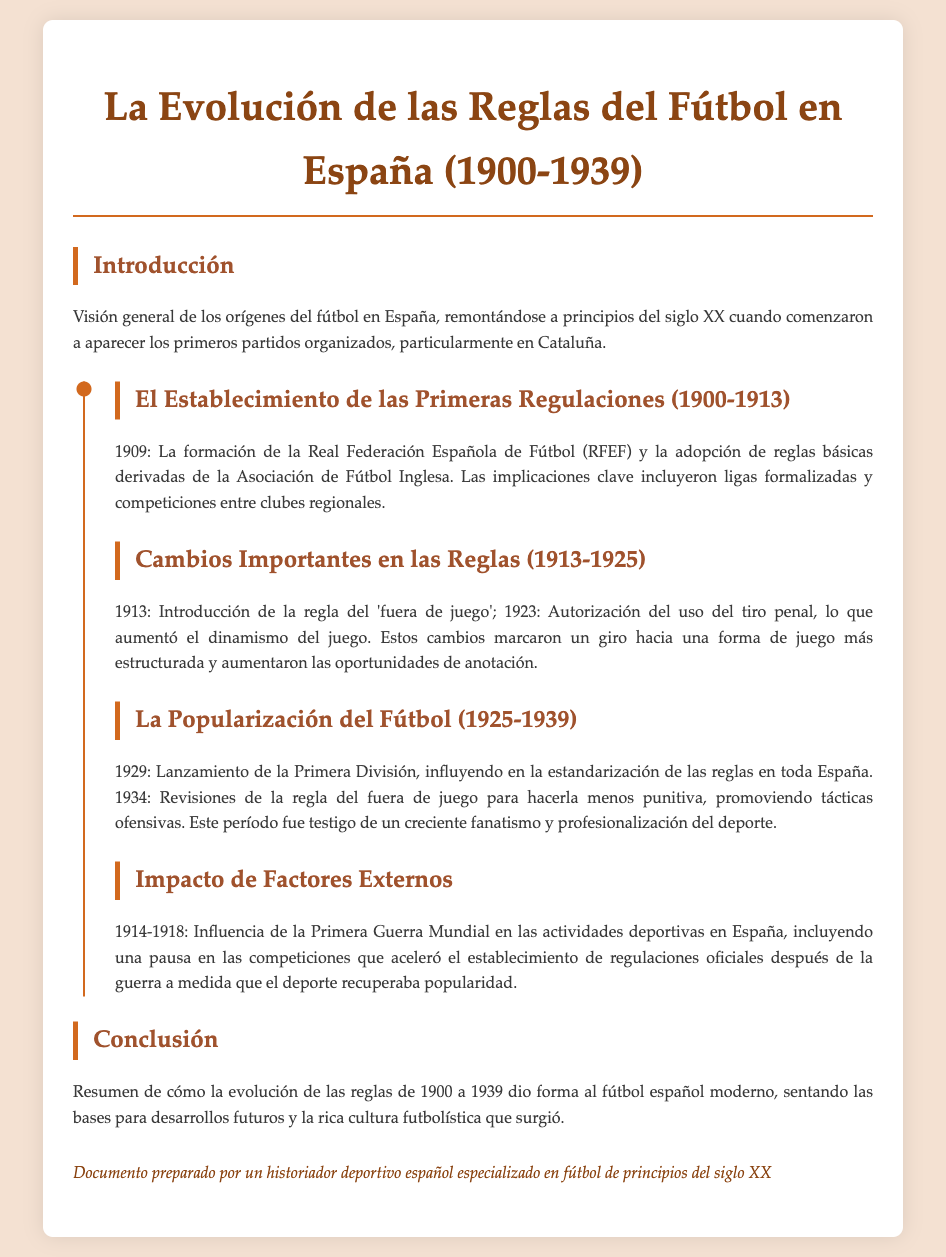¿Cuándo se formó la Real Federación Española de Fútbol? Se menciona que la RFEF se formó en 1909.
Answer: 1909 ¿Qué regla se introdujo en 1913? El documento menciona que la regla del 'fuera de juego' fue introducida en 1913.
Answer: regla del 'fuera de juego' ¿Cuál fue la fecha de lanzamiento de la Primera División? El lanzamiento de la Primera División ocurrió en 1929, según el documento.
Answer: 1929 ¿Qué cambio se realizó en la regla del fuera de juego en 1934? El documento indica que se revisó la regla del fuera de juego para hacerla menos punitiva en 1934.
Answer: menos punitiva ¿Qué evento mundial influyó en las actividades deportivas en España? El documento menciona la Primera Guerra Mundial como un evento que tuvo influencia.
Answer: Primera Guerra Mundial ¿Cuál fue una de las implicaciones clave de la formación de la RFEF? Se señala que una implicación fue la formalización de ligas y competiciones entre clubes regionales.
Answer: formalización de ligas ¿Cuántos años abarcan los cambios en las reglas citados en el documento? Los cambios en las reglas abarcan desde 1900 hasta 1939, lo que hace un total de 39 años.
Answer: 39 años ¿Qué periodo fue testigo de un creciente fanatismo por el fútbol? El documento menciona que el periodo entre 1925 y 1939 fue testigo de esto.
Answer: 1925-1939 